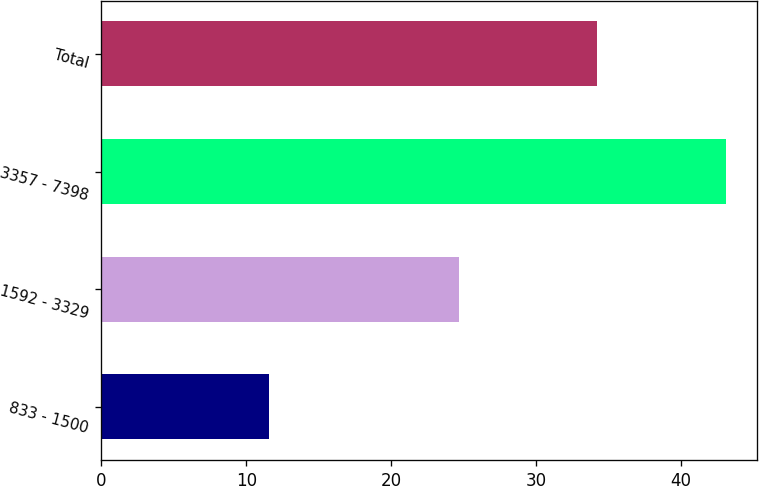Convert chart. <chart><loc_0><loc_0><loc_500><loc_500><bar_chart><fcel>833 - 1500<fcel>1592 - 3329<fcel>3357 - 7398<fcel>Total<nl><fcel>11.53<fcel>24.69<fcel>43.12<fcel>34.19<nl></chart> 